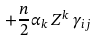Convert formula to latex. <formula><loc_0><loc_0><loc_500><loc_500>+ \frac { n } { 2 } \alpha _ { k } \, Z ^ { k } \, \gamma _ { i j }</formula> 